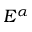<formula> <loc_0><loc_0><loc_500><loc_500>E ^ { \alpha }</formula> 